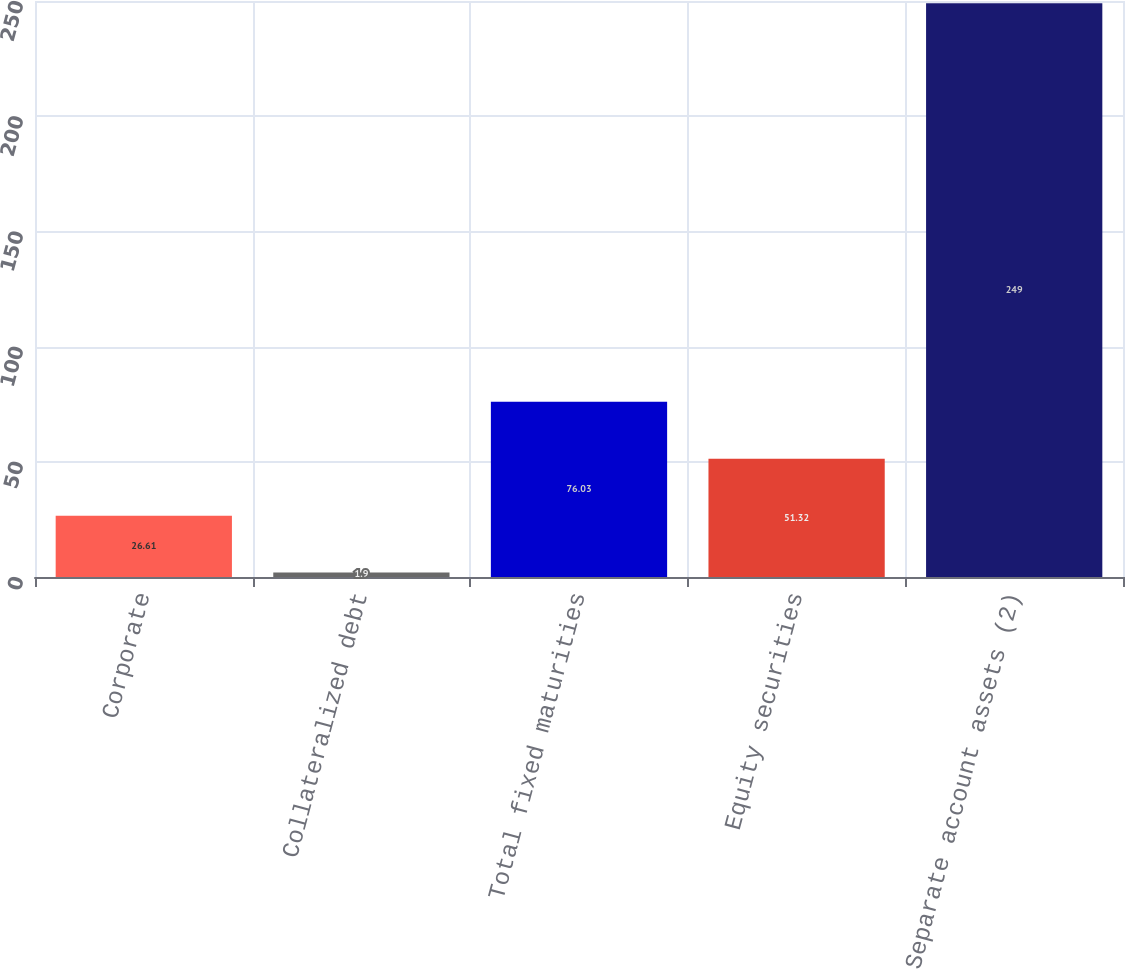<chart> <loc_0><loc_0><loc_500><loc_500><bar_chart><fcel>Corporate<fcel>Collateralized debt<fcel>Total fixed maturities<fcel>Equity securities<fcel>Separate account assets (2)<nl><fcel>26.61<fcel>1.9<fcel>76.03<fcel>51.32<fcel>249<nl></chart> 